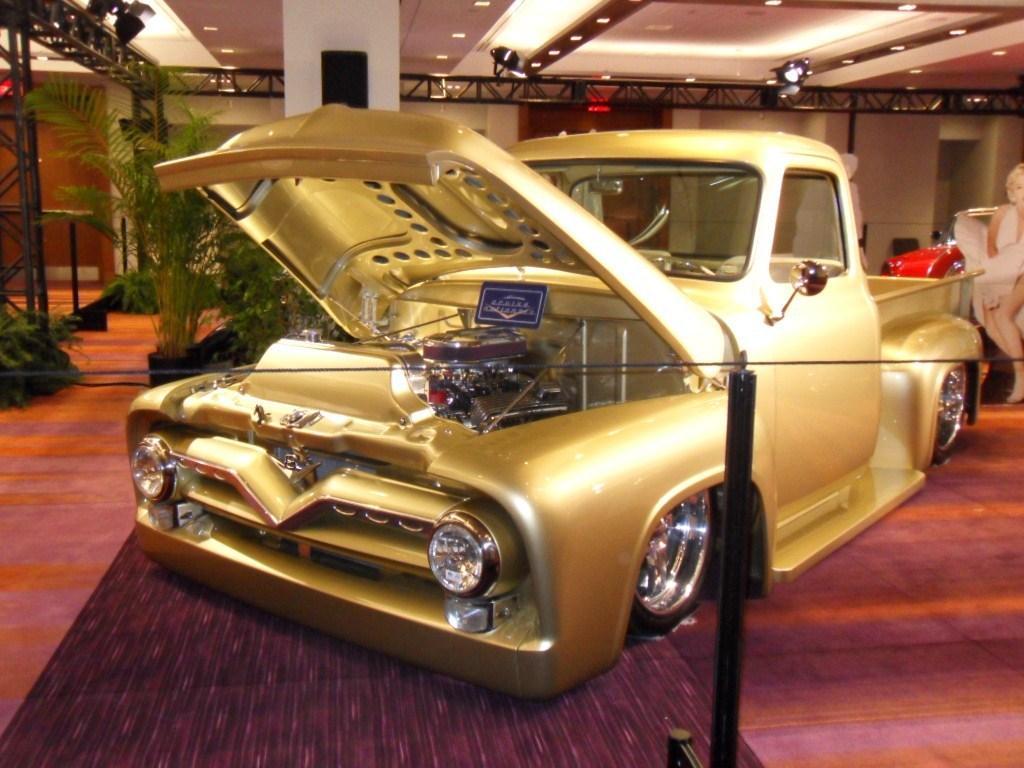Describe this image in one or two sentences. In this picture I can see a vehicle in front and I can see a black color pole on which there is wire. In the background I can see the rods and few plants on the left. On the top of this picture I can see the lights on the ceiling. 